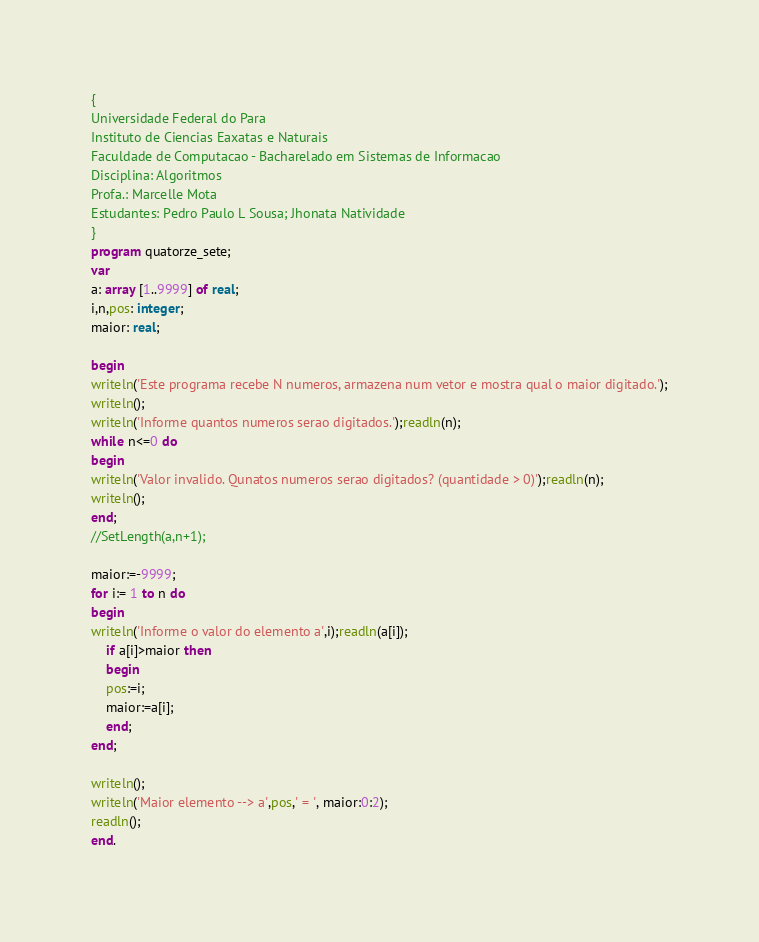<code> <loc_0><loc_0><loc_500><loc_500><_Pascal_>{
Universidade Federal do Para
Instituto de Ciencias Eaxatas e Naturais
Faculdade de Computacao - Bacharelado em Sistemas de Informacao
Disciplina: Algoritmos
Profa.: Marcelle Mota
Estudantes: Pedro Paulo L Sousa; Jhonata Natividade
}
program quatorze_sete;
var
a: array [1..9999] of real;
i,n,pos: integer;
maior: real;

begin
writeln('Este programa recebe N numeros, armazena num vetor e mostra qual o maior digitado.');
writeln();
writeln('Informe quantos numeros serao digitados.');readln(n);
while n<=0 do
begin
writeln('Valor invalido. Qunatos numeros serao digitados? (quantidade > 0)');readln(n);
writeln();
end;
//SetLength(a,n+1);

maior:=-9999;
for i:= 1 to n do
begin
writeln('Informe o valor do elemento a',i);readln(a[i]);
	if a[i]>maior then
	begin
	pos:=i;
	maior:=a[i];
	end;
end;

writeln();
writeln('Maior elemento --> a',pos,' = ', maior:0:2);
readln();
end.
</code> 